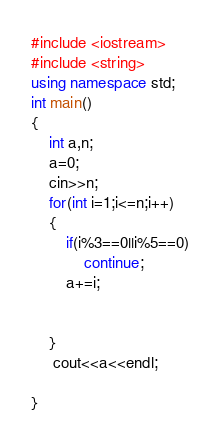<code> <loc_0><loc_0><loc_500><loc_500><_C++_>#include <iostream>
#include <string>
using namespace std;
int main()
{
    int a,n;
    a=0;
    cin>>n;
    for(int i=1;i<=n;i++)
    {
        if(i%3==0||i%5==0) 
            continue;
        a+=i;

        
    }
	 cout<<a<<endl;
    
}</code> 